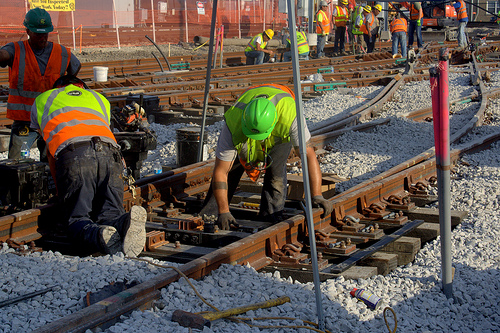<image>
Is there a fence behind the man? Yes. From this viewpoint, the fence is positioned behind the man, with the man partially or fully occluding the fence. Where is the hat in relation to the railroad track? Is it in the railroad track? No. The hat is not contained within the railroad track. These objects have a different spatial relationship. 